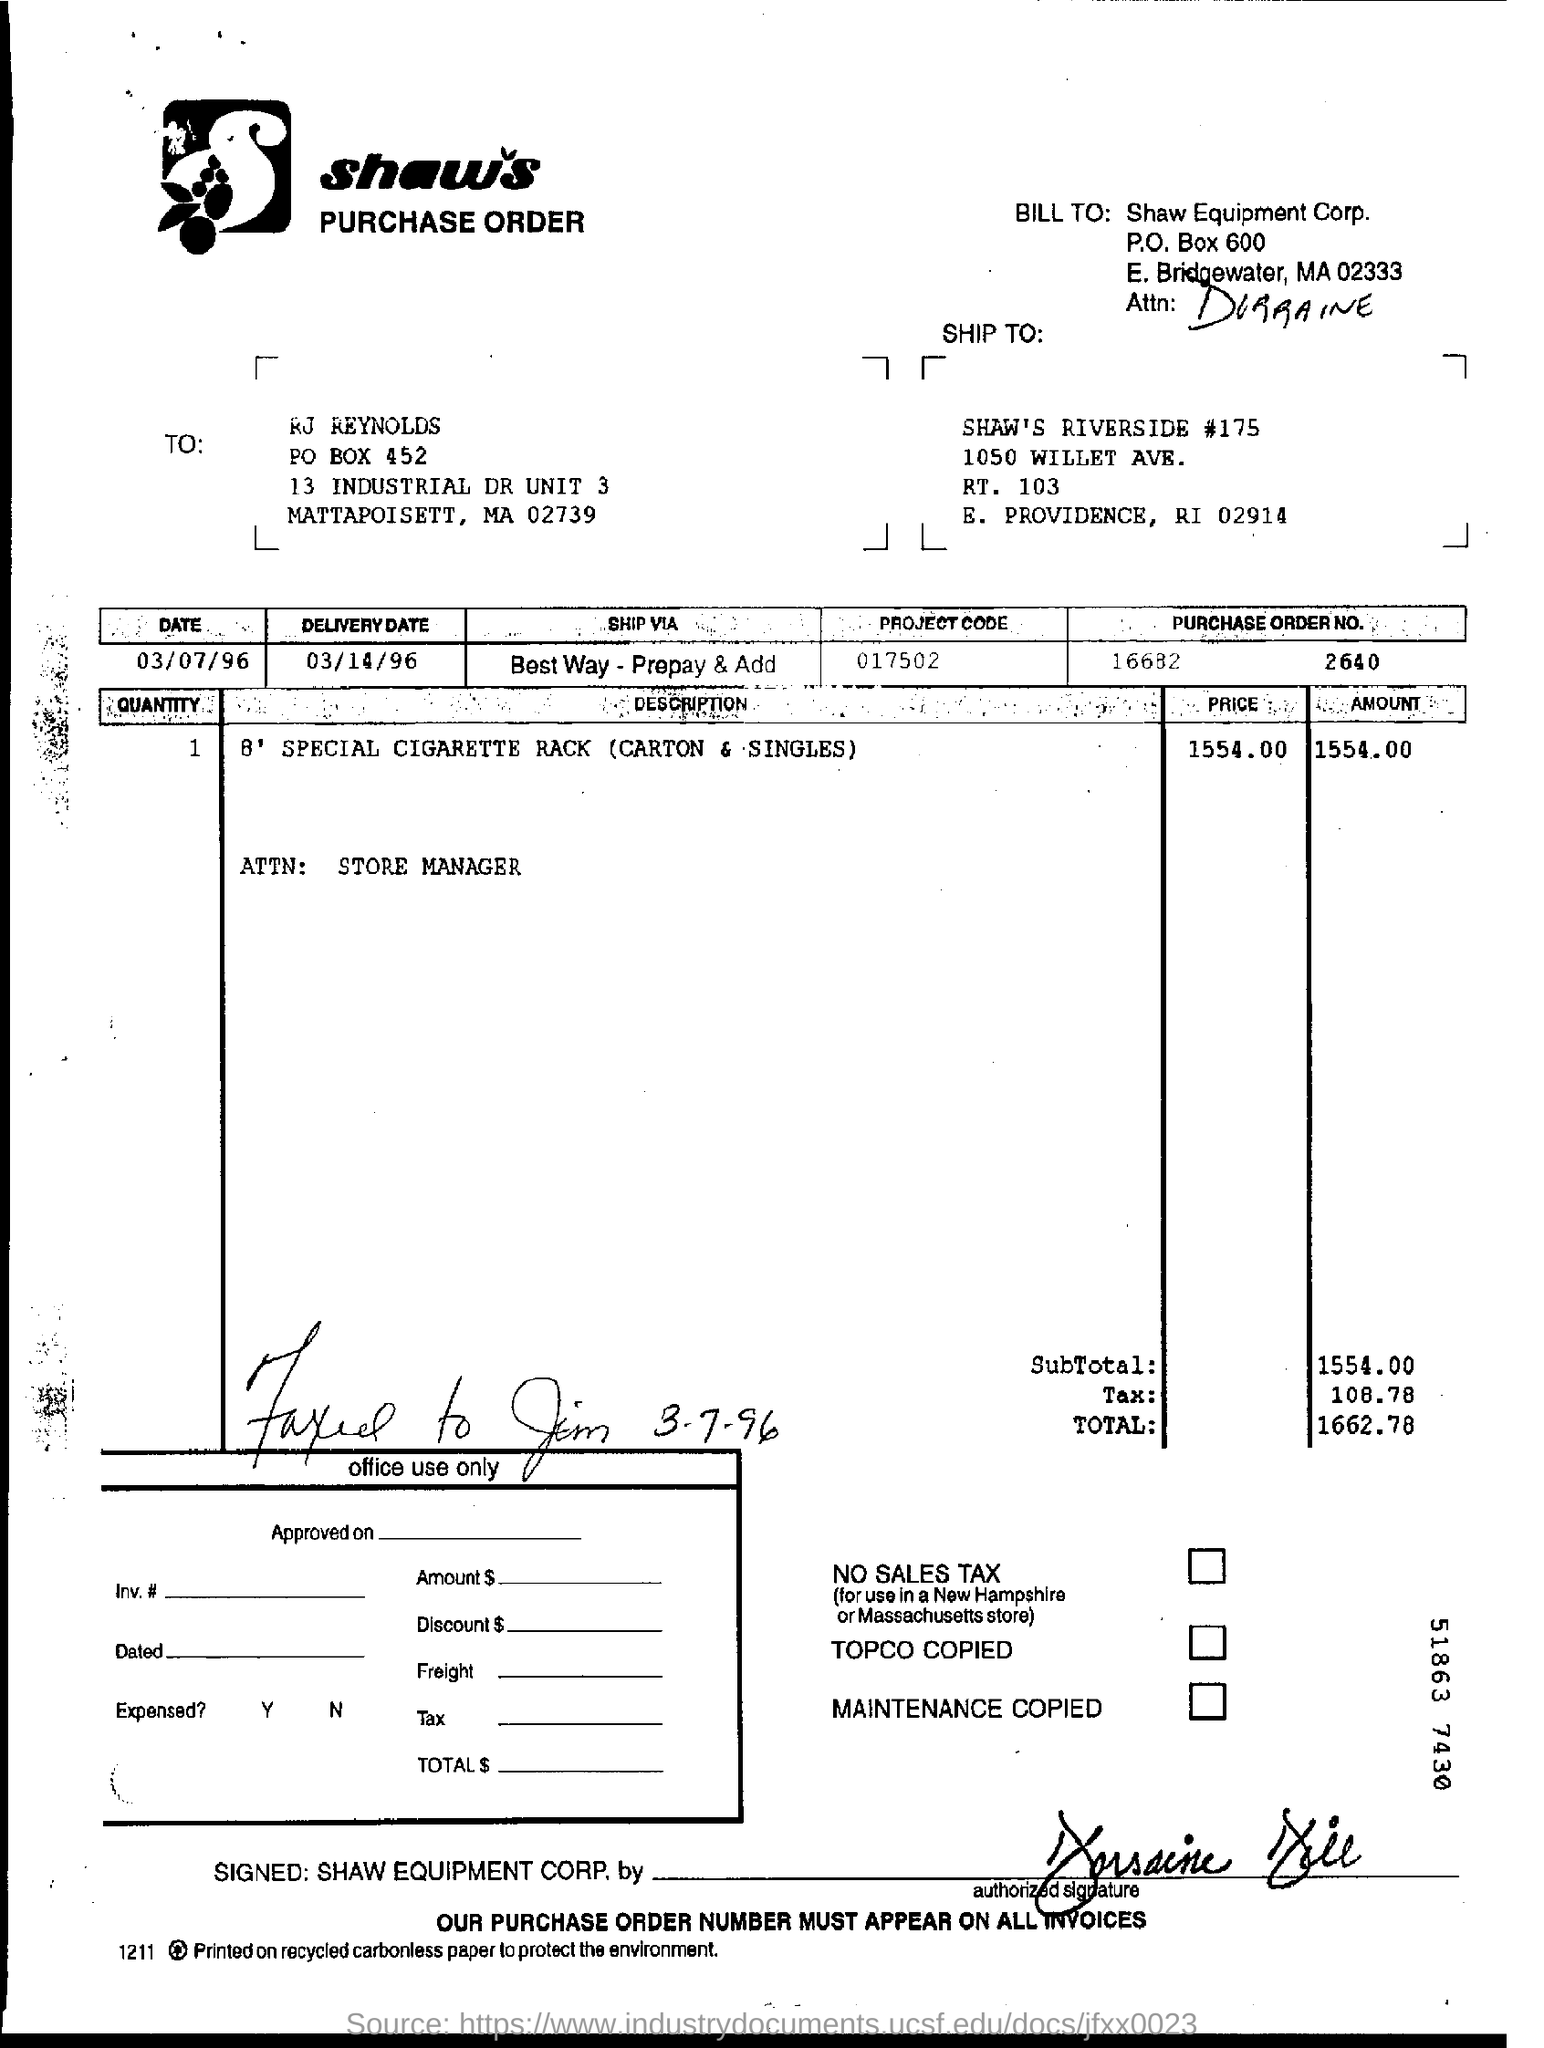List a handful of essential elements in this visual. The project code specified in the purchase order is 017502. The delivery date mentioned in the purchase order is 03/14/96. The total amount mentioned in the purchase order is 1662.78... 